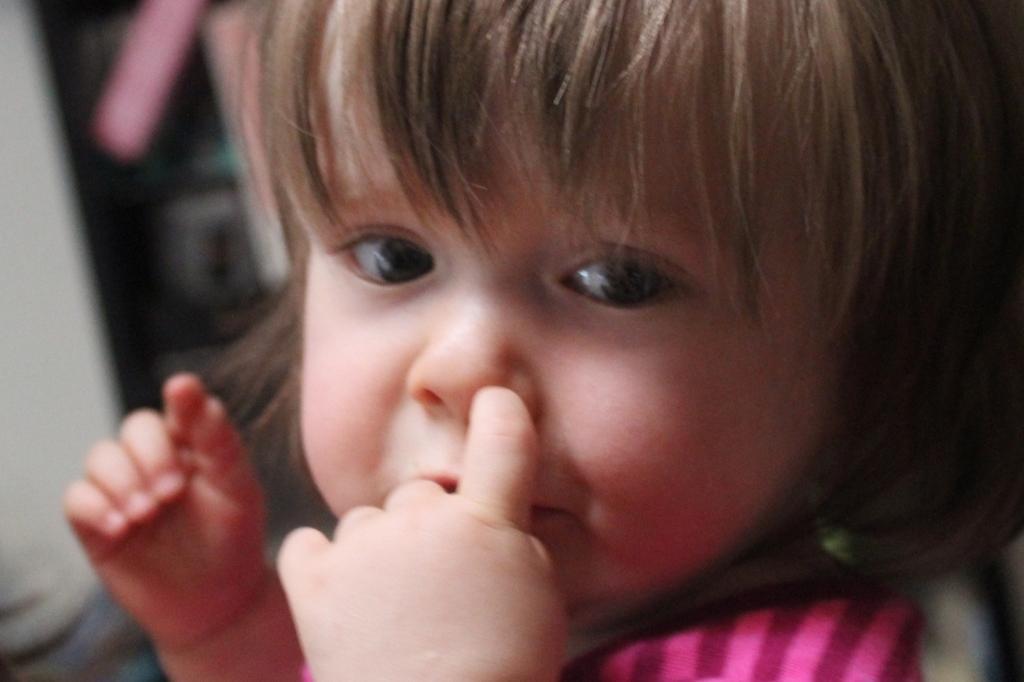In one or two sentences, can you explain what this image depicts? In the image I can see a girl. The background of the image is blurred. 